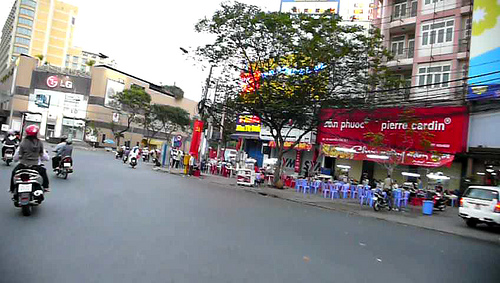On which side of the photo is the bike? The bike is positioned on the left side of the photo. 